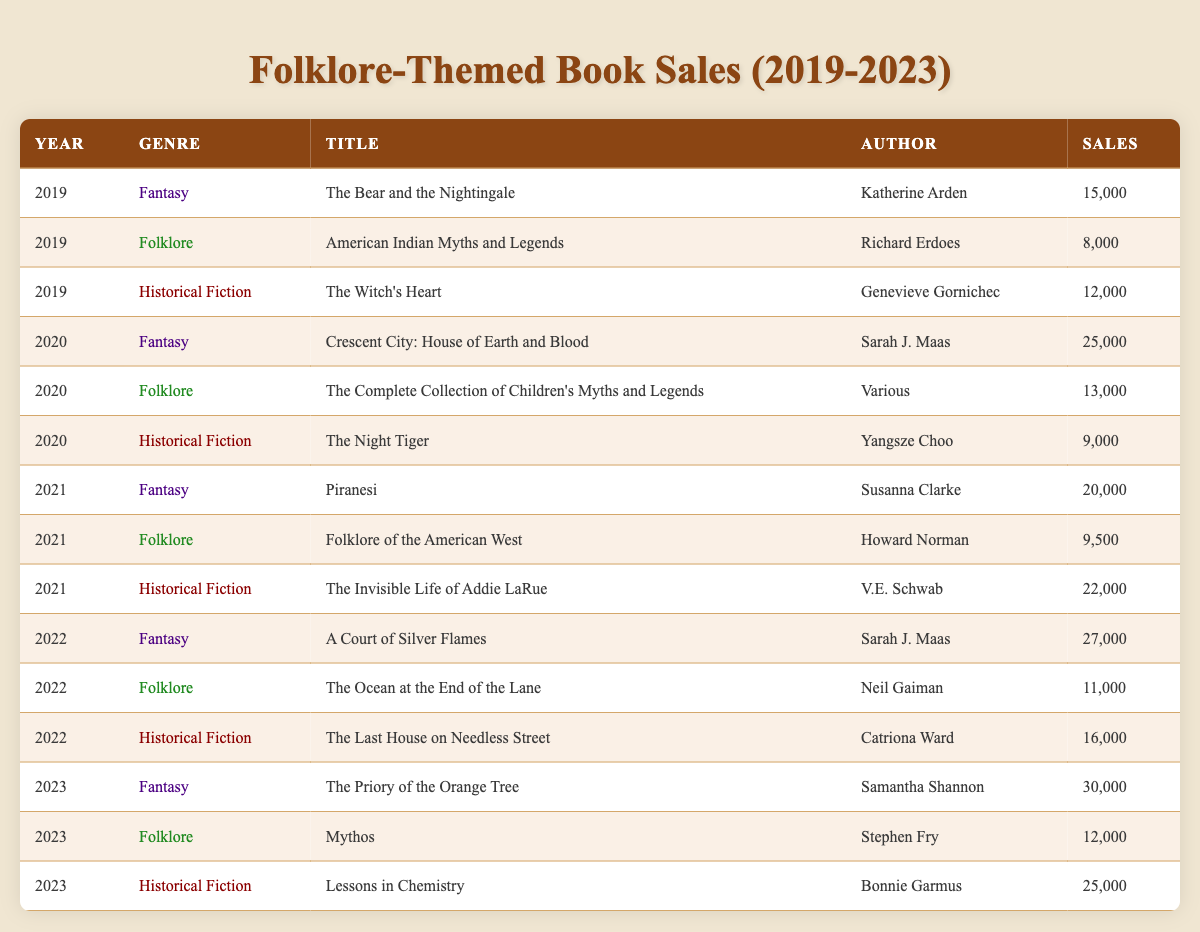What was the best-selling folklore-themed book in 2020? The highest sales figure for folklore in 2020 is 13,000 for "The Complete Collection of Children's Myths and Legends" by Various.
Answer: The Complete Collection of Children's Myths and Legends How many folklore-themed books were published in 2021? There are two entries under the folklore genre for the year 2021: "Folklore of the American West" and another title.
Answer: 2 What is the total sales figure for folklore-themed books from 2019 to 2022? Adding sales figures: 8,000 (2019) + 13,000 (2020) + 9,500 (2021) + 11,000 (2022) = 41,500.
Answer: 41,500 Was there a drop in sales for folklore-themed books from 2020 to 2021? In 2020, sales were 13,000, and in 2021, they dropped to 9,500, indicating a decrease.
Answer: Yes Which genre had the highest total sales in 2023, and what was the figure? For 2023, the fantasy genre had sales of 30,000, the highest compared to folklore and historical fiction.
Answer: Fantasy with 30,000 What is the average sales for folklore-themed books over the years? The sales for folklore-themed books across the years are: 8,000 (2019), 13,000 (2020), 9,500 (2021), 11,000 (2022), and 12,000 (2023). The total is 53,500 and there are 5 entries, so the average is 53,500 / 5 = 10,700.
Answer: 10,700 Which year had the lowest sales for folklore-themed books? In 2019, "American Indian Myths and Legends" had the lowest sales at 8,000 compared to other years.
Answer: 2019 How many more sales did the folklore-themed books make in 2022 compared to 2021? In 2022, folklore sales were 11,000, while in 2021 they were 9,500. The difference is 11,000 - 9,500 = 1,500.
Answer: 1,500 Are there any folklore-themed books that sold more than 10,000 copies in 2023? Yes, "Mythos" sold 12,000 copies in 2023, which is greater than 10,000.
Answer: Yes What was the total sales for fantasy books across all years? Total sales are calculated by summing: 15,000 (2019) + 25,000 (2020) + 20,000 (2021) + 27,000 (2022) + 30,000 (2023) = 117,000.
Answer: 117,000 Is it true that historical fiction books consistently sold more than folklore books from 2019 to 2023? Upon reviewing the sales data, historical fiction has higher sales in every year compared to folklore books.
Answer: Yes 